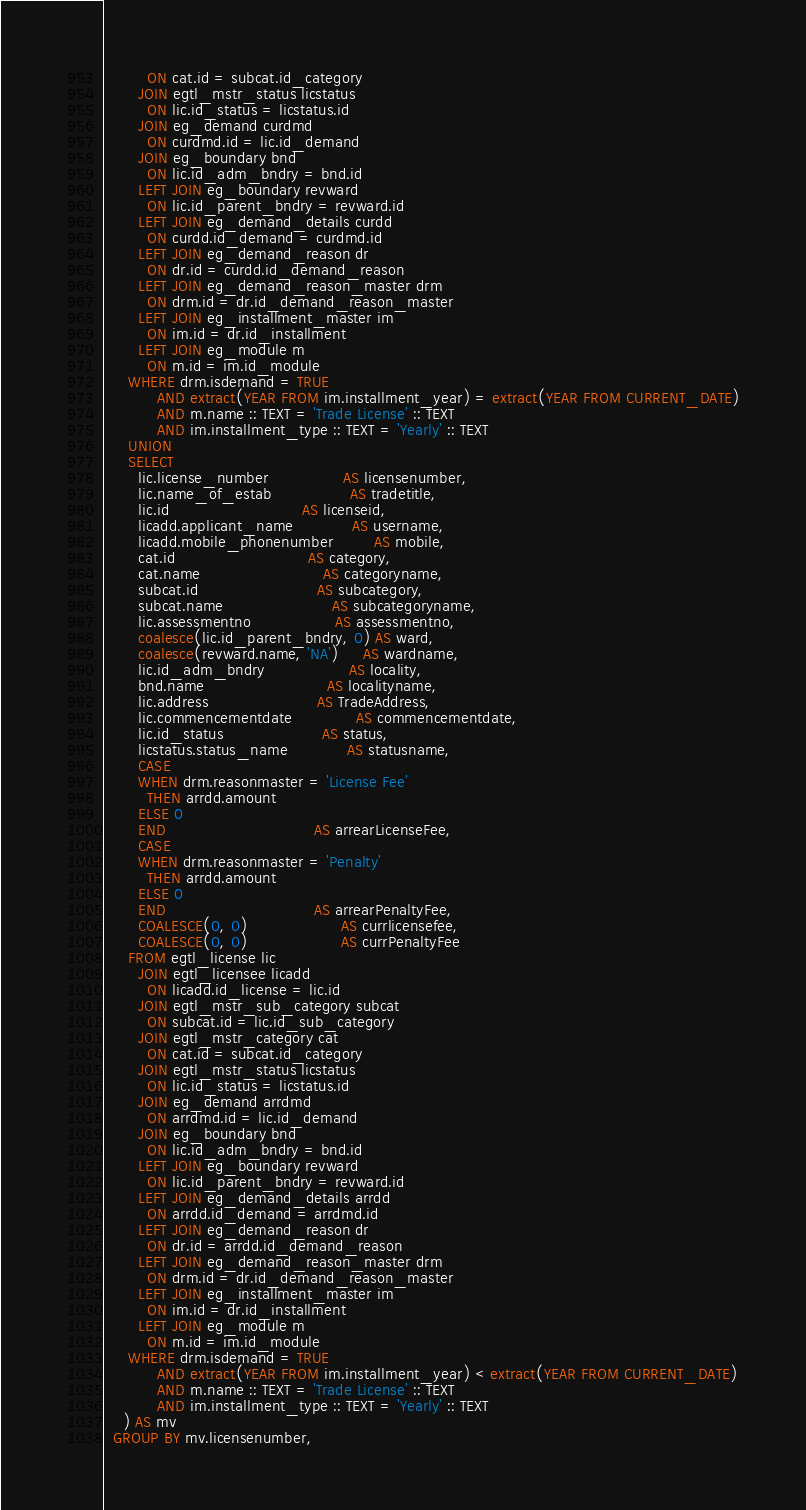Convert code to text. <code><loc_0><loc_0><loc_500><loc_500><_SQL_>         ON cat.id = subcat.id_category
       JOIN egtl_mstr_status licstatus
         ON lic.id_status = licstatus.id
       JOIN eg_demand curdmd
         ON curdmd.id = lic.id_demand
       JOIN eg_boundary bnd
         ON lic.id_adm_bndry = bnd.id
       LEFT JOIN eg_boundary revward
         ON lic.id_parent_bndry = revward.id
       LEFT JOIN eg_demand_details curdd
         ON curdd.id_demand = curdmd.id
       LEFT JOIN eg_demand_reason dr
         ON dr.id = curdd.id_demand_reason
       LEFT JOIN eg_demand_reason_master drm
         ON drm.id = dr.id_demand_reason_master
       LEFT JOIN eg_installment_master im
         ON im.id = dr.id_installment
       LEFT JOIN eg_module m
         ON m.id = im.id_module
     WHERE drm.isdemand = TRUE
           AND extract(YEAR FROM im.installment_year) = extract(YEAR FROM CURRENT_DATE)
           AND m.name :: TEXT = 'Trade License' :: TEXT
           AND im.installment_type :: TEXT = 'Yearly' :: TEXT
     UNION
     SELECT
       lic.license_number               AS licensenumber,
       lic.name_of_estab                AS tradetitle,
       lic.id                           AS licenseid,
       licadd.applicant_name            AS username,
       licadd.mobile_phonenumber        AS mobile,
       cat.id                           AS category,
       cat.name                         AS categoryname,
       subcat.id                        AS subcategory,
       subcat.name                      AS subcategoryname,
       lic.assessmentno                 AS assessmentno,
       coalesce(lic.id_parent_bndry, 0) AS ward,
       coalesce(revward.name, 'NA')     AS wardname,
       lic.id_adm_bndry                 AS locality,
       bnd.name                         AS localityname,
       lic.address                      AS TradeAddress,
       lic.commencementdate             AS commencementdate,
       lic.id_status                    AS status,
       licstatus.status_name            AS statusname,
       CASE
       WHEN drm.reasonmaster = 'License Fee'
         THEN arrdd.amount
       ELSE 0
       END                              AS arrearLicenseFee,
       CASE
       WHEN drm.reasonmaster = 'Penalty'
         THEN arrdd.amount
       ELSE 0
       END                              AS arrearPenaltyFee,
       COALESCE(0, 0)                   AS currlicensefee,
       COALESCE(0, 0)                   AS currPenaltyFee
     FROM egtl_license lic
       JOIN egtl_licensee licadd
         ON licadd.id_license = lic.id
       JOIN egtl_mstr_sub_category subcat
         ON subcat.id = lic.id_sub_category
       JOIN egtl_mstr_category cat
         ON cat.id = subcat.id_category
       JOIN egtl_mstr_status licstatus
         ON lic.id_status = licstatus.id
       JOIN eg_demand arrdmd
         ON arrdmd.id = lic.id_demand
       JOIN eg_boundary bnd
         ON lic.id_adm_bndry = bnd.id
       LEFT JOIN eg_boundary revward
         ON lic.id_parent_bndry = revward.id
       LEFT JOIN eg_demand_details arrdd
         ON arrdd.id_demand = arrdmd.id
       LEFT JOIN eg_demand_reason dr
         ON dr.id = arrdd.id_demand_reason
       LEFT JOIN eg_demand_reason_master drm
         ON drm.id = dr.id_demand_reason_master
       LEFT JOIN eg_installment_master im
         ON im.id = dr.id_installment
       LEFT JOIN eg_module m
         ON m.id = im.id_module
     WHERE drm.isdemand = TRUE
           AND extract(YEAR FROM im.installment_year) < extract(YEAR FROM CURRENT_DATE)
           AND m.name :: TEXT = 'Trade License' :: TEXT
           AND im.installment_type :: TEXT = 'Yearly' :: TEXT
    ) AS mv
  GROUP BY mv.licensenumber,</code> 